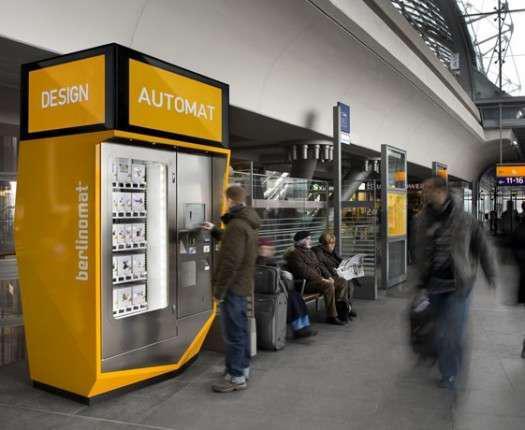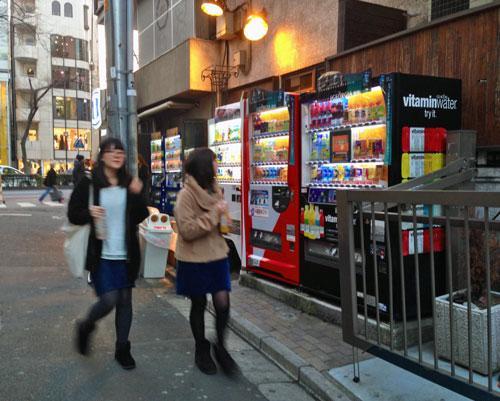The first image is the image on the left, the second image is the image on the right. Examine the images to the left and right. Is the description "there are no humans in front of the vending machine" accurate? Answer yes or no. No. 